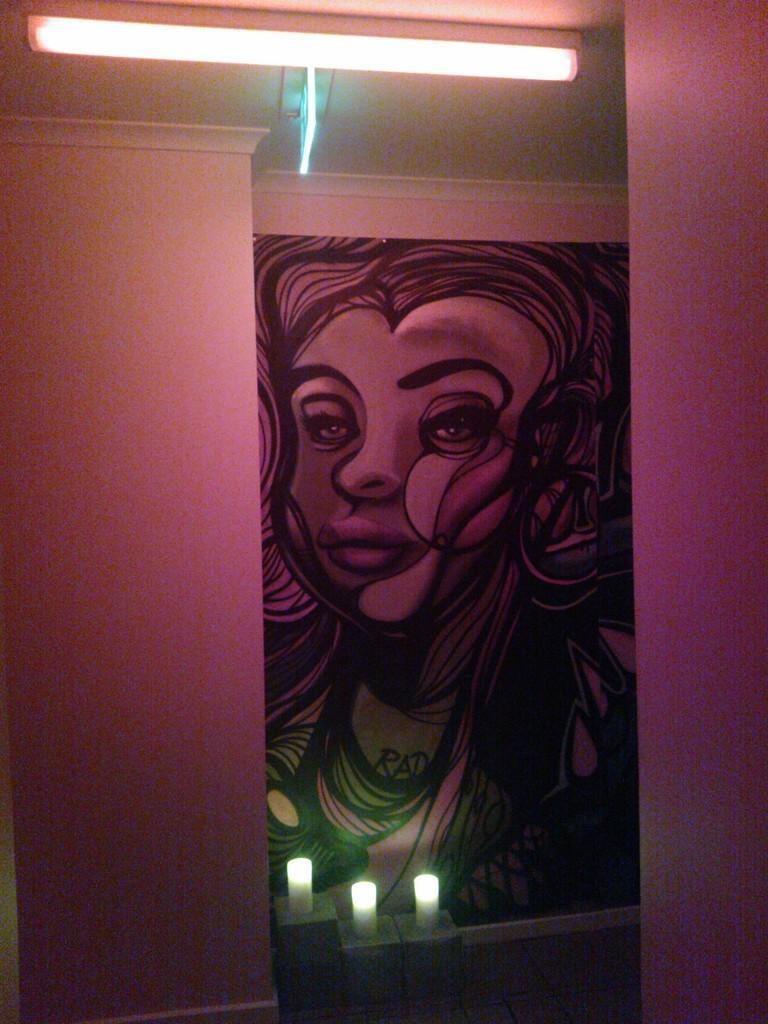In one or two sentences, can you explain what this image depicts? In this picture, we can see an inner view of the room, and we can see the wall with poster of an art, and we can see the roof with lights, we can see the floor and some objects with lights. 